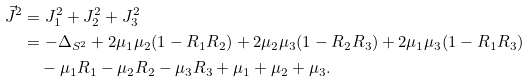<formula> <loc_0><loc_0><loc_500><loc_500>\vec { J } ^ { 2 } & = J _ { 1 } ^ { 2 } + J _ { 2 } ^ { 2 } + J _ { 3 } ^ { 2 } \\ & = - \Delta _ { S ^ { 2 } } + 2 \mu _ { 1 } \mu _ { 2 } ( 1 - R _ { 1 } R _ { 2 } ) + 2 \mu _ { 2 } \mu _ { 3 } ( 1 - R _ { 2 } R _ { 3 } ) + 2 \mu _ { 1 } \mu _ { 3 } ( 1 - R _ { 1 } R _ { 3 } ) \\ & \quad - \mu _ { 1 } R _ { 1 } - \mu _ { 2 } R _ { 2 } - \mu _ { 3 } R _ { 3 } + \mu _ { 1 } + \mu _ { 2 } + \mu _ { 3 } .</formula> 